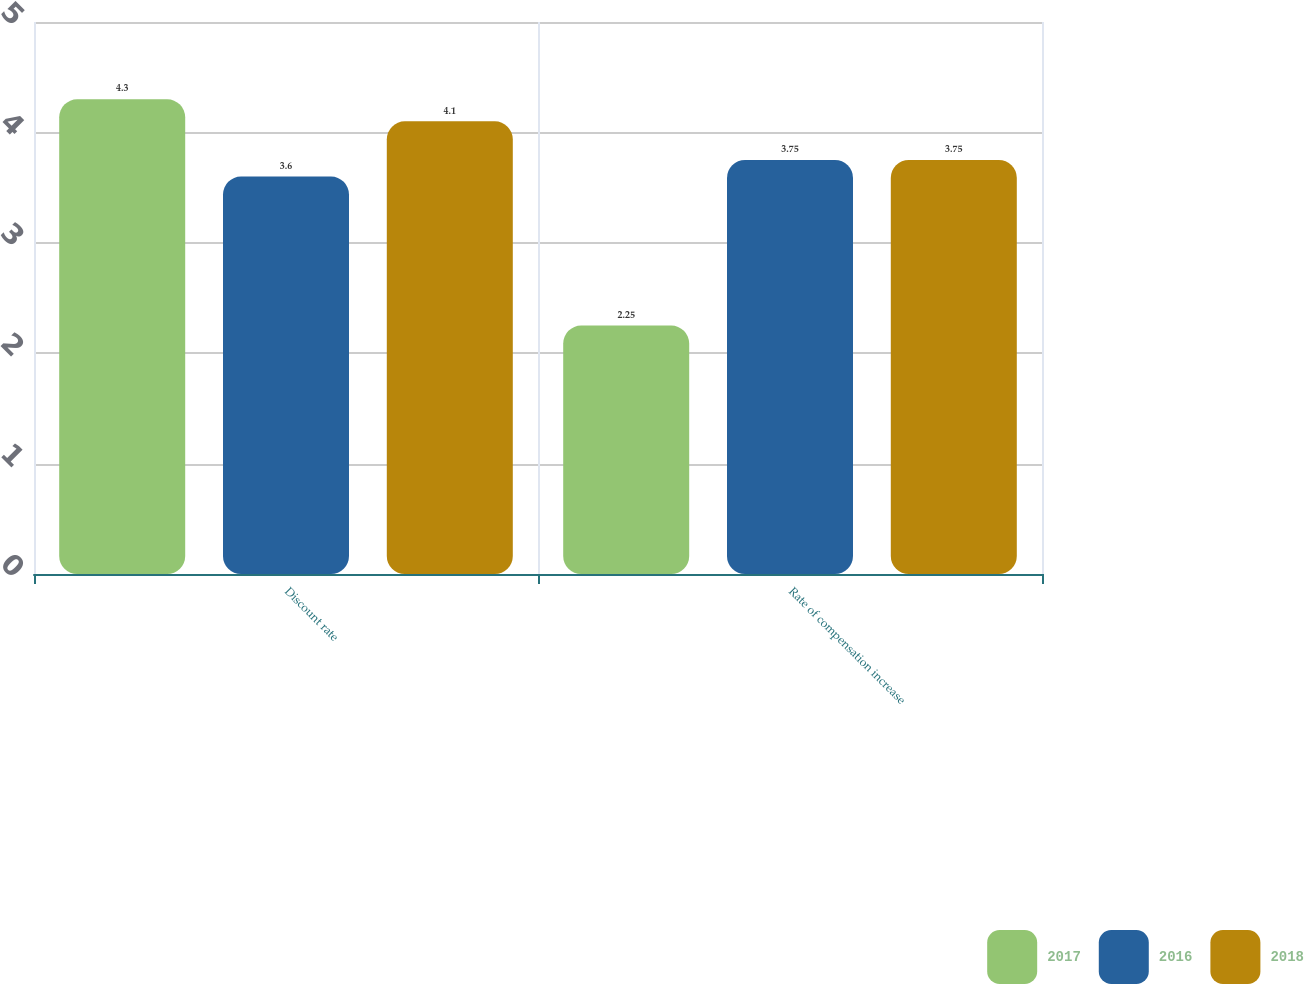<chart> <loc_0><loc_0><loc_500><loc_500><stacked_bar_chart><ecel><fcel>Discount rate<fcel>Rate of compensation increase<nl><fcel>2017<fcel>4.3<fcel>2.25<nl><fcel>2016<fcel>3.6<fcel>3.75<nl><fcel>2018<fcel>4.1<fcel>3.75<nl></chart> 